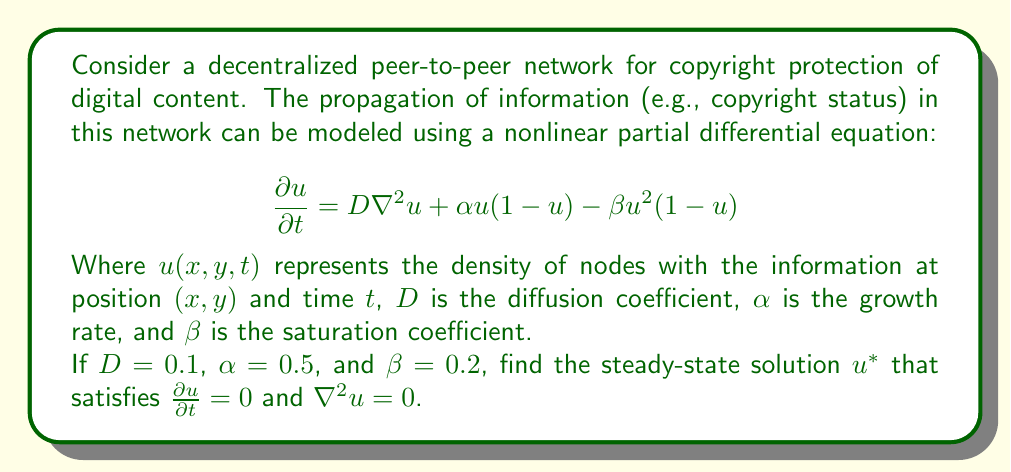Give your solution to this math problem. To find the steady-state solution, we follow these steps:

1) Set $\frac{\partial u}{\partial t} = 0$ and $\nabla^2u = 0$ in the original equation:

   $$0 = D(0) + \alpha u(1-u) - \beta u^2(1-u)$$

2) Simplify:

   $$0 = \alpha u(1-u) - \beta u^2(1-u)$$

3) Factor out $(1-u)$:

   $$0 = (\alpha u - \beta u^2)(1-u)$$

4) This equation is satisfied when either $(1-u) = 0$ or $(\alpha u - \beta u^2) = 0$

5) From $(1-u) = 0$, we get $u = 1$

6) From $(\alpha u - \beta u^2) = 0$:
   
   $$\alpha u - \beta u^2 = 0$$
   $$u(\alpha - \beta u) = 0$$

   This gives us $u = 0$ or $u = \frac{\alpha}{\beta}$

7) Substitute the given values $\alpha = 0.5$ and $\beta = 0.2$:

   $$u = \frac{0.5}{0.2} = 2.5$$

8) However, since $u$ represents a density, it must be between 0 and 1.

Therefore, the valid steady-state solutions are $u^* = 0$ and $u^* = 1$.
Answer: $u^* = 0$ or $u^* = 1$ 